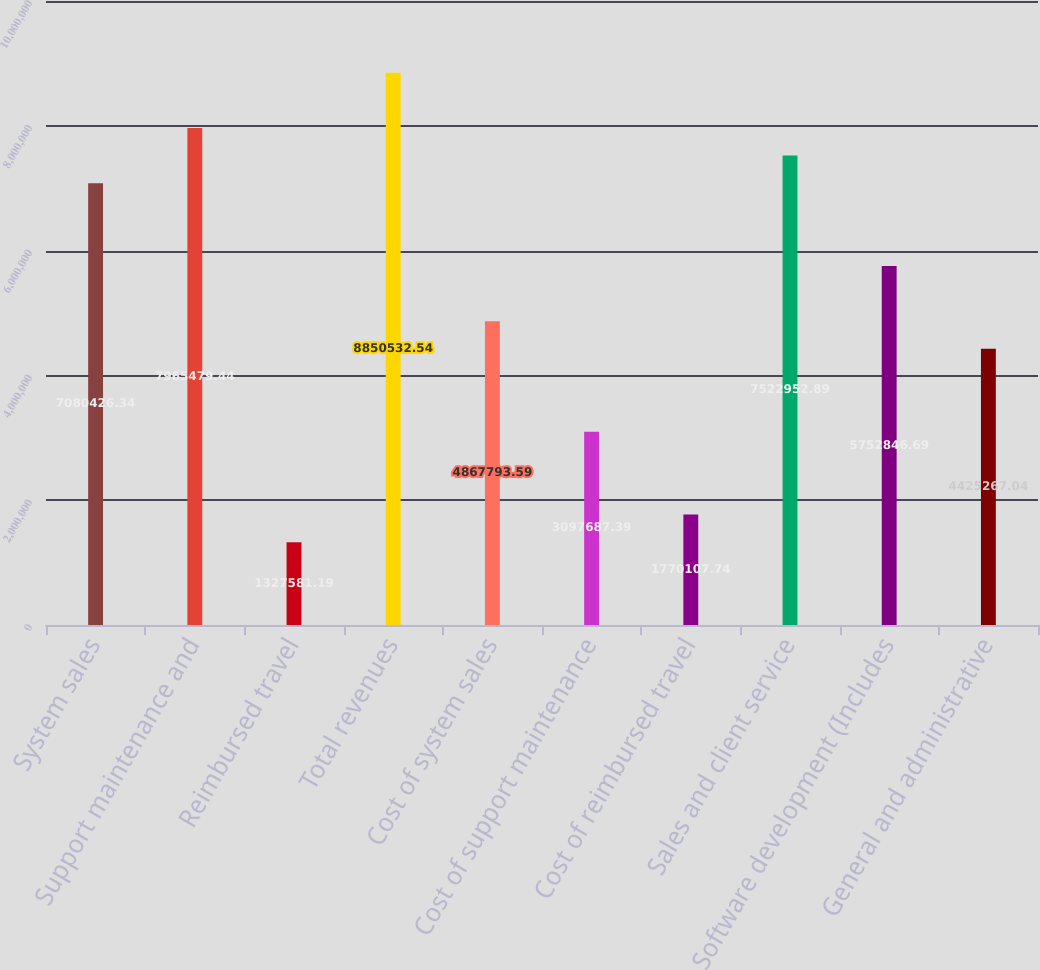<chart> <loc_0><loc_0><loc_500><loc_500><bar_chart><fcel>System sales<fcel>Support maintenance and<fcel>Reimbursed travel<fcel>Total revenues<fcel>Cost of system sales<fcel>Cost of support maintenance<fcel>Cost of reimbursed travel<fcel>Sales and client service<fcel>Software development (Includes<fcel>General and administrative<nl><fcel>7.08043e+06<fcel>7.96548e+06<fcel>1.32758e+06<fcel>8.85053e+06<fcel>4.86779e+06<fcel>3.09769e+06<fcel>1.77011e+06<fcel>7.52295e+06<fcel>5.75285e+06<fcel>4.42527e+06<nl></chart> 